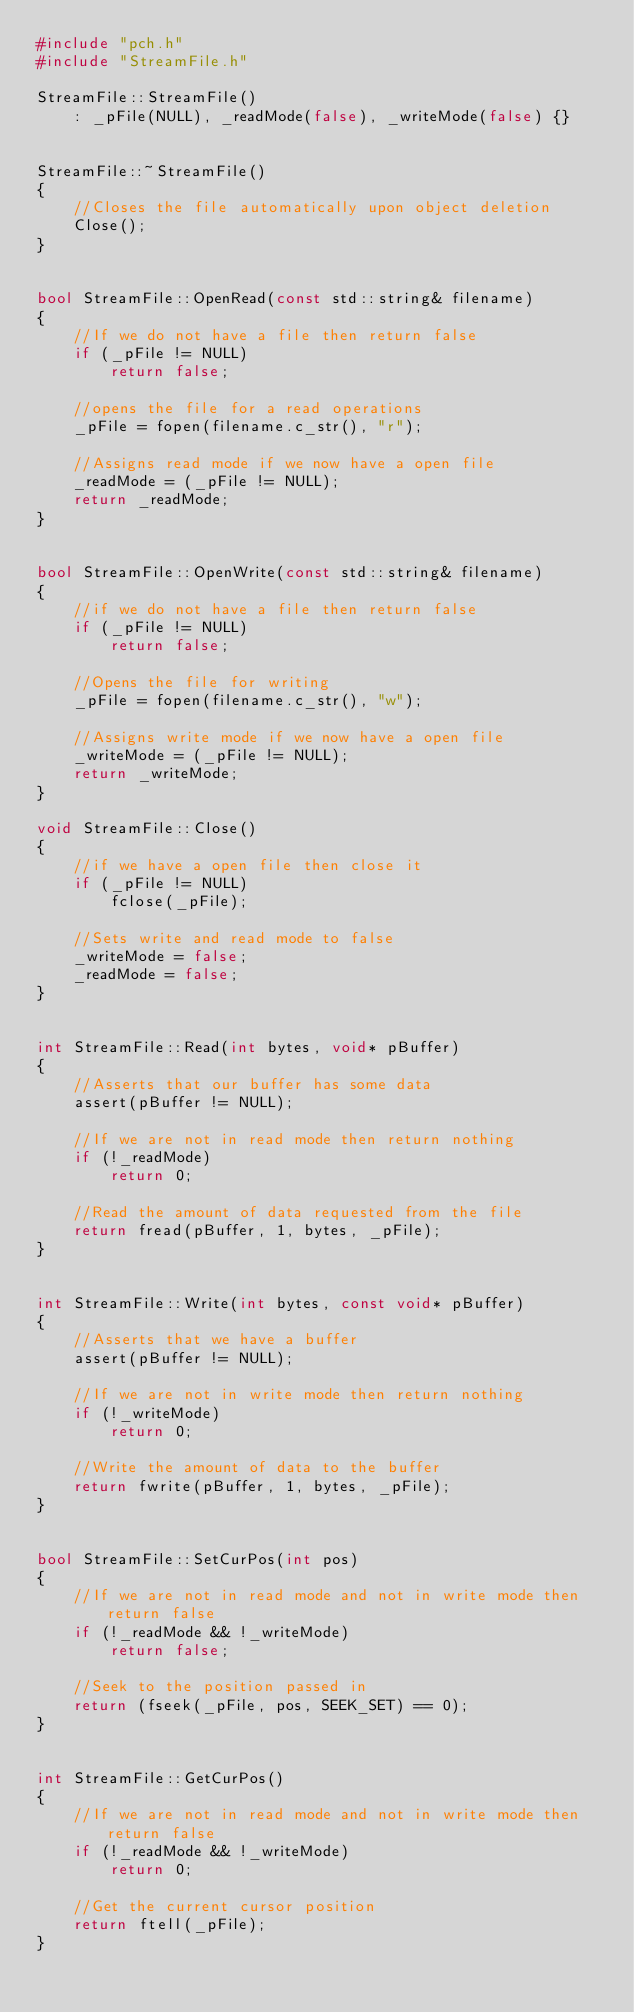<code> <loc_0><loc_0><loc_500><loc_500><_C++_>#include "pch.h"
#include "StreamFile.h"

StreamFile::StreamFile()
	: _pFile(NULL), _readMode(false), _writeMode(false) {}


StreamFile::~StreamFile()
{
	//Closes the file automatically upon object deletion
	Close();
}


bool StreamFile::OpenRead(const std::string& filename)
{
	//If we do not have a file then return false
	if (_pFile != NULL)
		return false;

	//opens the file for a read operations
	_pFile = fopen(filename.c_str(), "r");

	//Assigns read mode if we now have a open file
	_readMode = (_pFile != NULL);
	return _readMode;
}


bool StreamFile::OpenWrite(const std::string& filename)
{
	//if we do not have a file then return false
	if (_pFile != NULL)
		return false;

	//Opens the file for writing
	_pFile = fopen(filename.c_str(), "w");

	//Assigns write mode if we now have a open file
	_writeMode = (_pFile != NULL);
	return _writeMode;
}

void StreamFile::Close()
{
	//if we have a open file then close it
	if (_pFile != NULL)
		fclose(_pFile);

	//Sets write and read mode to false
	_writeMode = false;
	_readMode = false;
}


int StreamFile::Read(int bytes, void* pBuffer)
{
	//Asserts that our buffer has some data
	assert(pBuffer != NULL);

	//If we are not in read mode then return nothing
	if (!_readMode)
		return 0;

	//Read the amount of data requested from the file
	return fread(pBuffer, 1, bytes, _pFile);
}


int StreamFile::Write(int bytes, const void* pBuffer)
{
	//Asserts that we have a buffer
	assert(pBuffer != NULL);

	//If we are not in write mode then return nothing
	if (!_writeMode)
		return 0;

	//Write the amount of data to the buffer
	return fwrite(pBuffer, 1, bytes, _pFile);
}


bool StreamFile::SetCurPos(int pos)
{
	//If we are not in read mode and not in write mode then return false
	if (!_readMode && !_writeMode)
		return false;

	//Seek to the position passed in
	return (fseek(_pFile, pos, SEEK_SET) == 0);
}


int StreamFile::GetCurPos()
{
	//If we are not in read mode and not in write mode then return false
	if (!_readMode && !_writeMode)
		return 0;

	//Get the current cursor position
	return ftell(_pFile);
}

</code> 